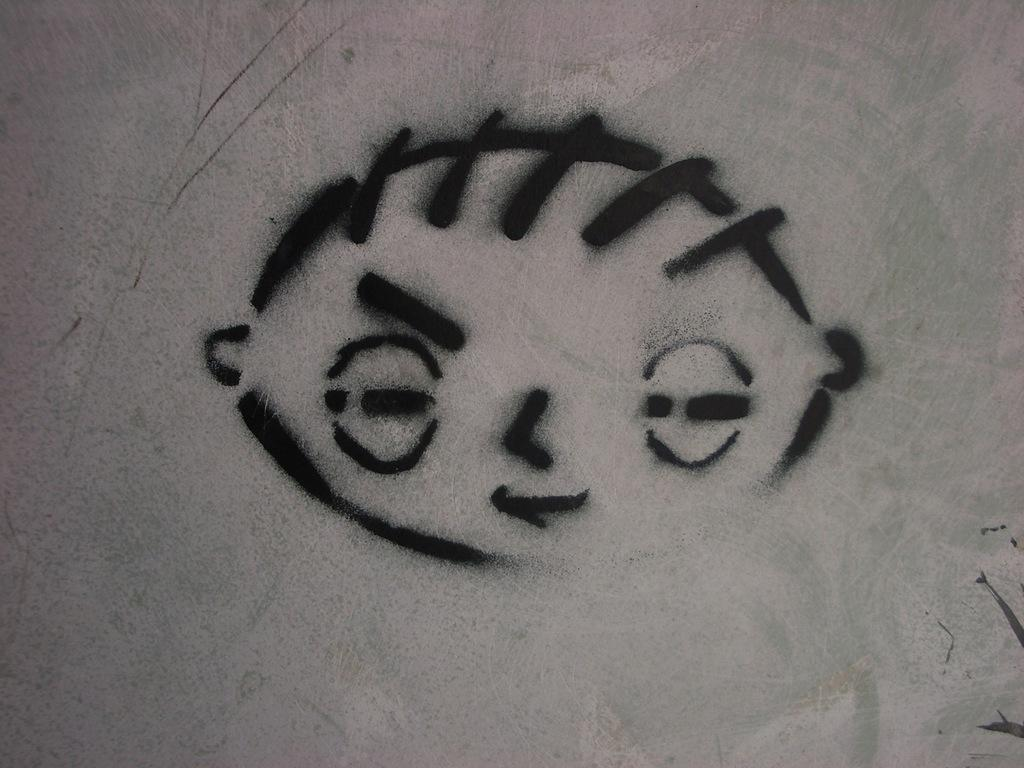What type of artwork is displayed in the image? The image is a painting on the wall. What subject matter is depicted in the painting? The painting appears to depict a face. What scent is associated with the painting in the image? There is no scent associated with the painting in the image, as it is a visual representation and not a physical object. 